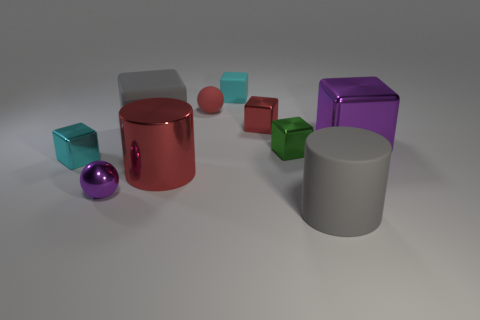Subtract 2 blocks. How many blocks are left? 4 Subtract all red blocks. How many blocks are left? 5 Subtract all gray cubes. How many cubes are left? 5 Subtract all cyan blocks. Subtract all gray spheres. How many blocks are left? 4 Subtract all cylinders. How many objects are left? 8 Subtract all blocks. Subtract all red matte balls. How many objects are left? 3 Add 6 gray rubber blocks. How many gray rubber blocks are left? 7 Add 8 large gray cylinders. How many large gray cylinders exist? 9 Subtract 0 cyan cylinders. How many objects are left? 10 